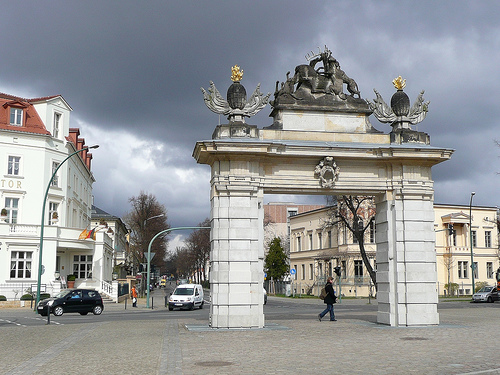<image>
Is there a woman to the right of the arch? No. The woman is not to the right of the arch. The horizontal positioning shows a different relationship. 